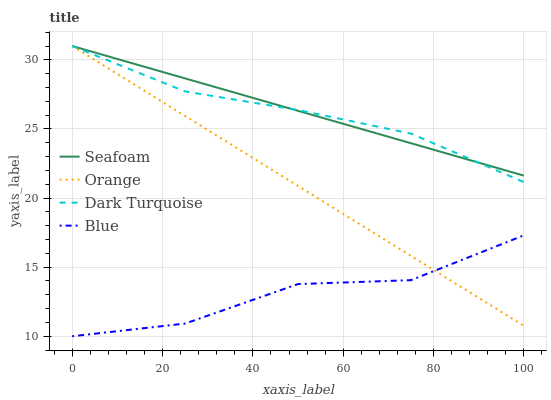Does Blue have the minimum area under the curve?
Answer yes or no. Yes. Does Seafoam have the maximum area under the curve?
Answer yes or no. Yes. Does Dark Turquoise have the minimum area under the curve?
Answer yes or no. No. Does Dark Turquoise have the maximum area under the curve?
Answer yes or no. No. Is Orange the smoothest?
Answer yes or no. Yes. Is Blue the roughest?
Answer yes or no. Yes. Is Dark Turquoise the smoothest?
Answer yes or no. No. Is Dark Turquoise the roughest?
Answer yes or no. No. Does Blue have the lowest value?
Answer yes or no. Yes. Does Dark Turquoise have the lowest value?
Answer yes or no. No. Does Seafoam have the highest value?
Answer yes or no. Yes. Does Blue have the highest value?
Answer yes or no. No. Is Blue less than Seafoam?
Answer yes or no. Yes. Is Seafoam greater than Blue?
Answer yes or no. Yes. Does Seafoam intersect Dark Turquoise?
Answer yes or no. Yes. Is Seafoam less than Dark Turquoise?
Answer yes or no. No. Is Seafoam greater than Dark Turquoise?
Answer yes or no. No. Does Blue intersect Seafoam?
Answer yes or no. No. 